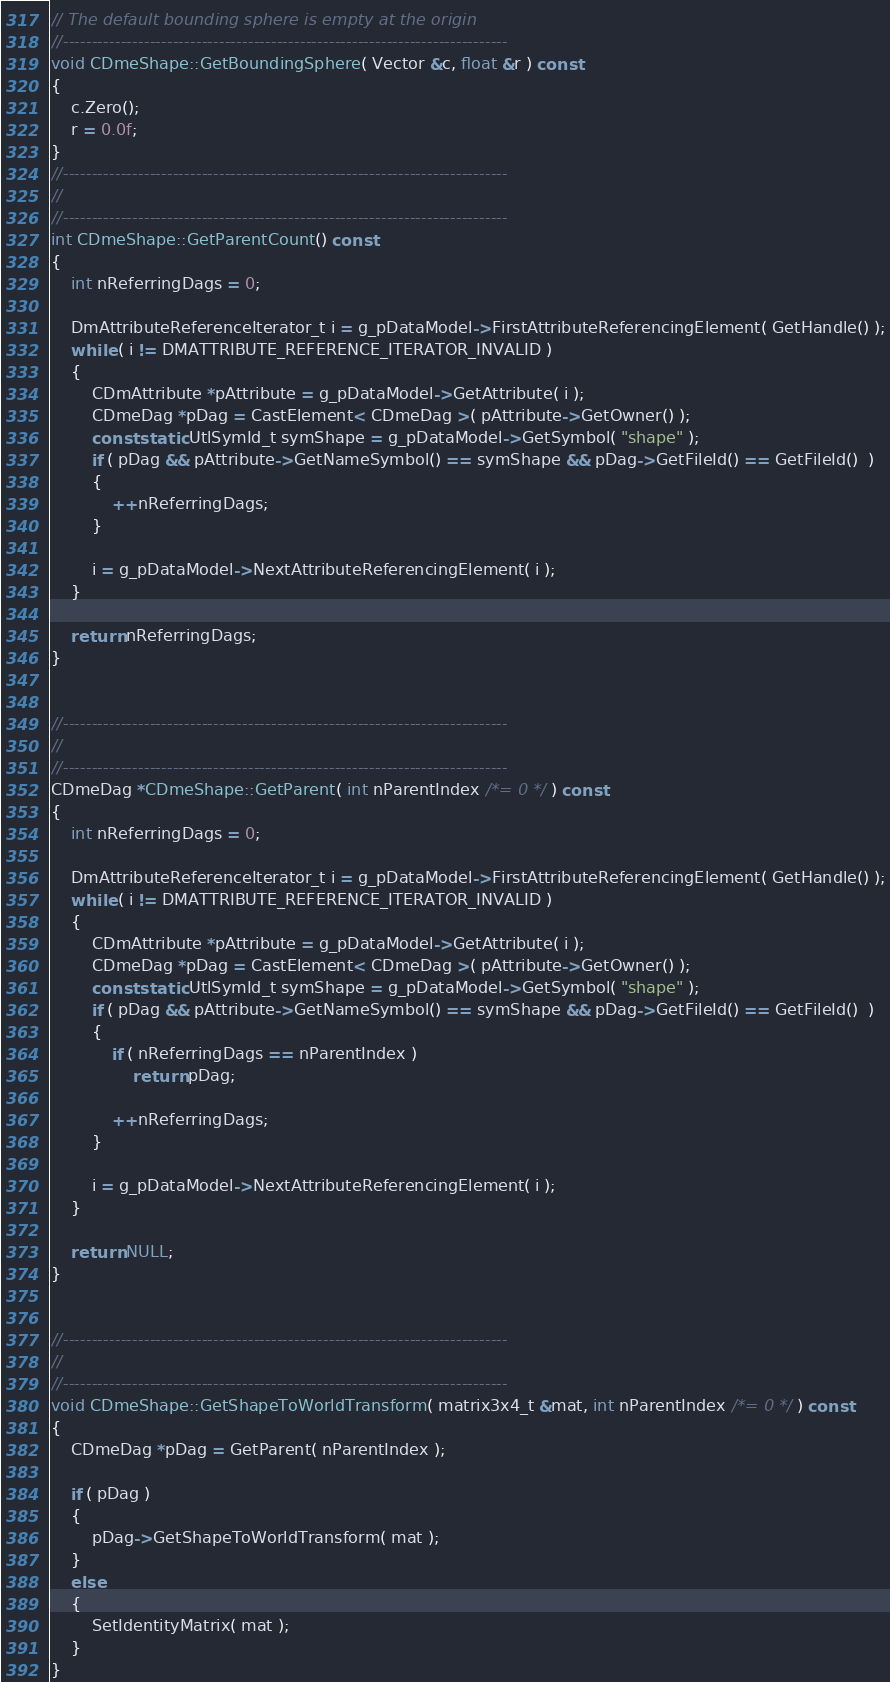Convert code to text. <code><loc_0><loc_0><loc_500><loc_500><_C++_>// The default bounding sphere is empty at the origin
//-----------------------------------------------------------------------------
void CDmeShape::GetBoundingSphere( Vector &c, float &r ) const
{
	c.Zero();
	r = 0.0f;
}
//-----------------------------------------------------------------------------
//
//-----------------------------------------------------------------------------
int CDmeShape::GetParentCount() const
{
	int nReferringDags = 0;

	DmAttributeReferenceIterator_t i = g_pDataModel->FirstAttributeReferencingElement( GetHandle() );
	while ( i != DMATTRIBUTE_REFERENCE_ITERATOR_INVALID )
	{
		CDmAttribute *pAttribute = g_pDataModel->GetAttribute( i );
		CDmeDag *pDag = CastElement< CDmeDag >( pAttribute->GetOwner() );
		const static UtlSymId_t symShape = g_pDataModel->GetSymbol( "shape" );
		if ( pDag && pAttribute->GetNameSymbol() == symShape && pDag->GetFileId() == GetFileId()  )
		{
			++nReferringDags;
		}

		i = g_pDataModel->NextAttributeReferencingElement( i );
	}

	return nReferringDags;
}


//-----------------------------------------------------------------------------
//
//-----------------------------------------------------------------------------
CDmeDag *CDmeShape::GetParent( int nParentIndex /*= 0 */ ) const
{
	int nReferringDags = 0;

	DmAttributeReferenceIterator_t i = g_pDataModel->FirstAttributeReferencingElement( GetHandle() );
	while ( i != DMATTRIBUTE_REFERENCE_ITERATOR_INVALID )
	{
		CDmAttribute *pAttribute = g_pDataModel->GetAttribute( i );
		CDmeDag *pDag = CastElement< CDmeDag >( pAttribute->GetOwner() );
		const static UtlSymId_t symShape = g_pDataModel->GetSymbol( "shape" );
		if ( pDag && pAttribute->GetNameSymbol() == symShape && pDag->GetFileId() == GetFileId()  )
		{
			if ( nReferringDags == nParentIndex )
				return pDag;

			++nReferringDags;
		}

		i = g_pDataModel->NextAttributeReferencingElement( i );
	}

	return NULL;
}


//-----------------------------------------------------------------------------
//
//-----------------------------------------------------------------------------
void CDmeShape::GetShapeToWorldTransform( matrix3x4_t &mat, int nParentIndex /*= 0 */ ) const
{
	CDmeDag *pDag = GetParent( nParentIndex );

	if ( pDag )
	{
		pDag->GetShapeToWorldTransform( mat );
	}
	else
	{
		SetIdentityMatrix( mat );
	}
}
</code> 